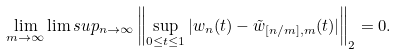<formula> <loc_0><loc_0><loc_500><loc_500>\lim _ { m \to \infty } \lim s u p _ { n \to \infty } \left \| \sup _ { 0 \leq t \leq 1 } | w _ { n } ( t ) - \tilde { w } _ { [ n / m ] , m } ( t ) | \right \| _ { 2 } = 0 .</formula> 